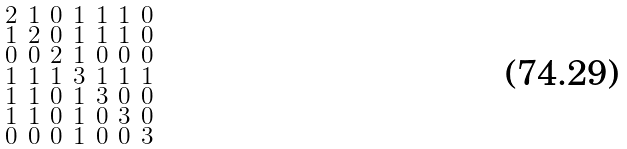Convert formula to latex. <formula><loc_0><loc_0><loc_500><loc_500>\begin{smallmatrix} 2 & 1 & 0 & 1 & 1 & 1 & 0 \\ 1 & 2 & 0 & 1 & 1 & 1 & 0 \\ 0 & 0 & 2 & 1 & 0 & 0 & 0 \\ 1 & 1 & 1 & 3 & 1 & 1 & 1 \\ 1 & 1 & 0 & 1 & 3 & 0 & 0 \\ 1 & 1 & 0 & 1 & 0 & 3 & 0 \\ 0 & 0 & 0 & 1 & 0 & 0 & 3 \end{smallmatrix}</formula> 